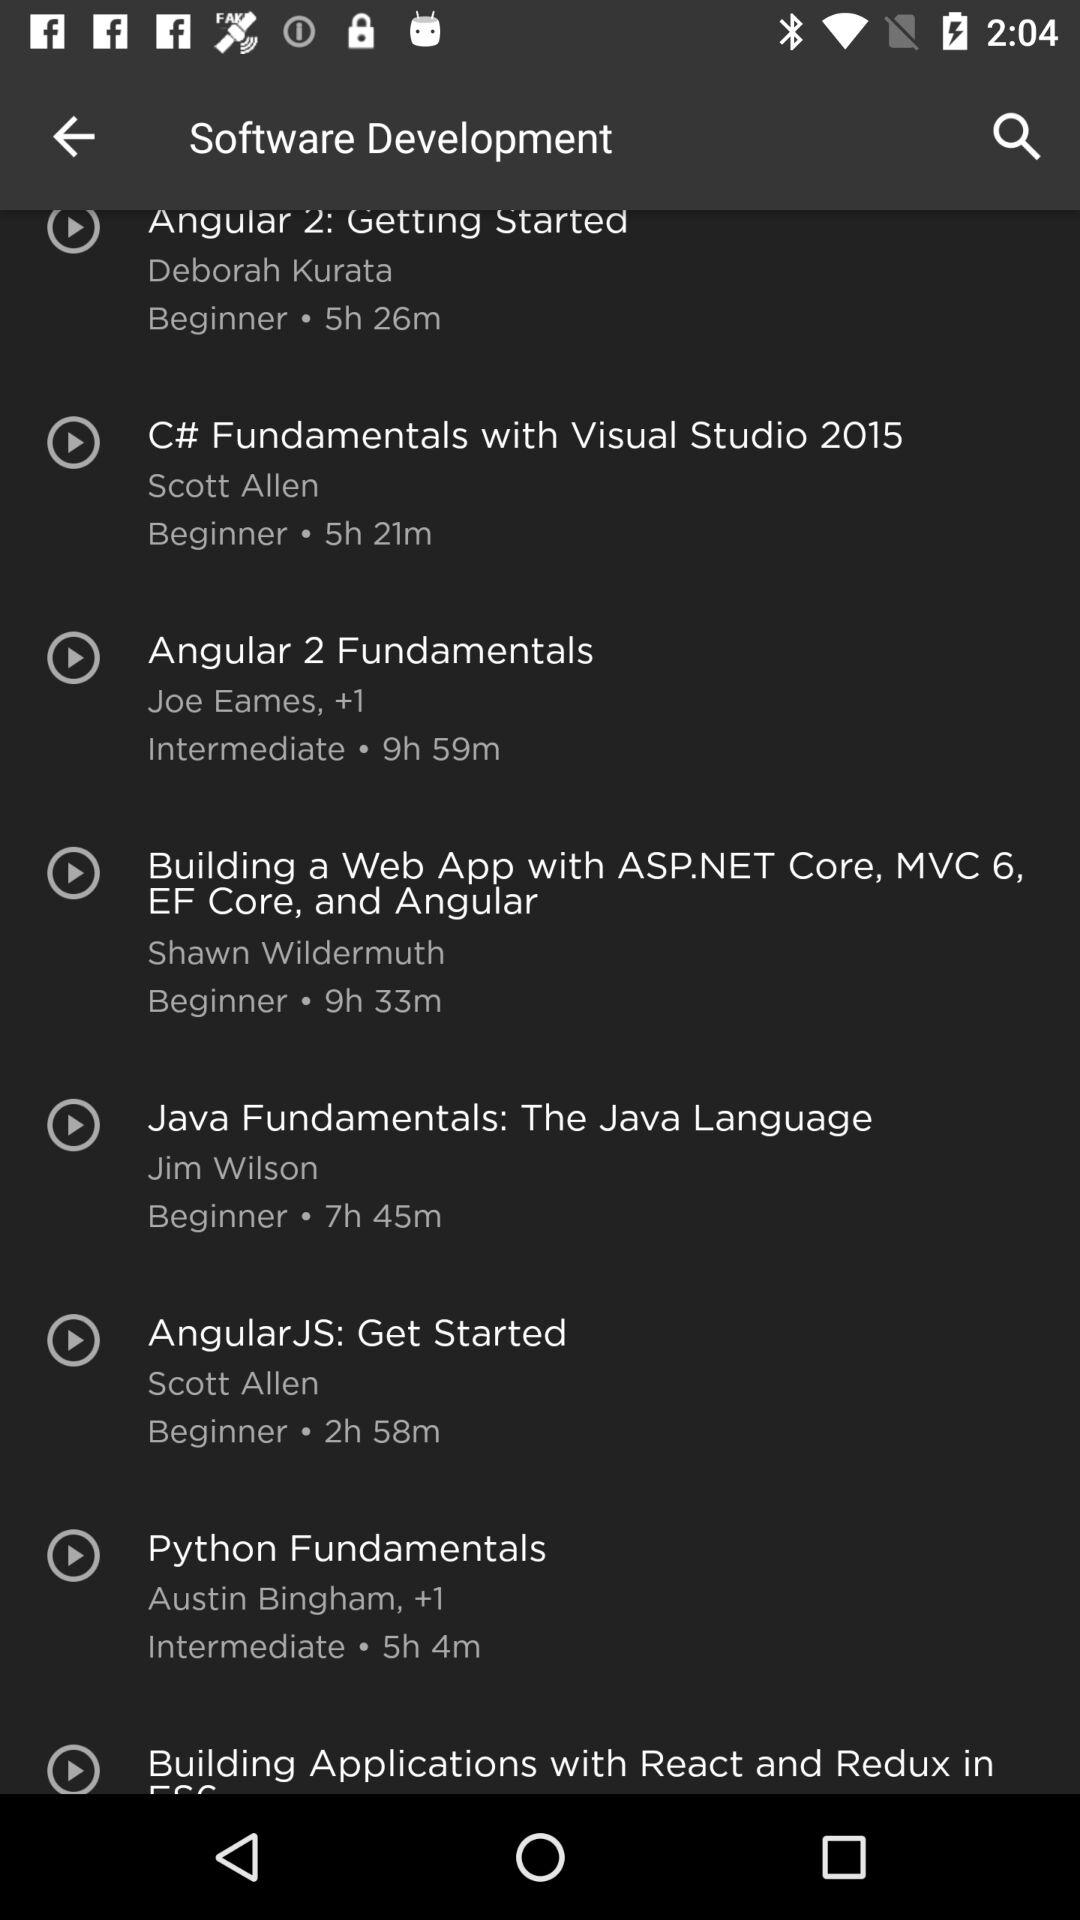How many courses are offered in the Software Development category?
Answer the question using a single word or phrase. 8 